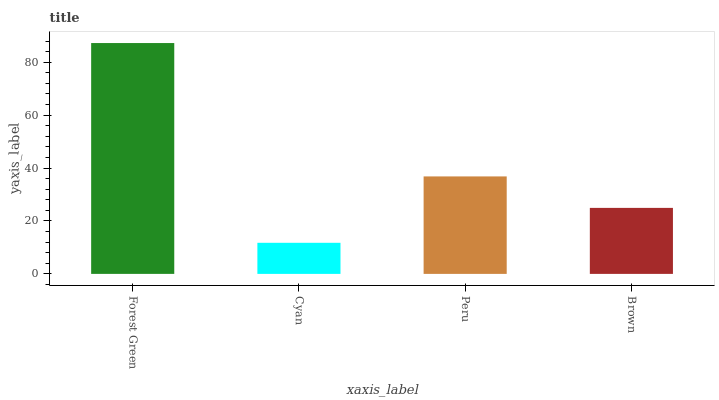Is Cyan the minimum?
Answer yes or no. Yes. Is Forest Green the maximum?
Answer yes or no. Yes. Is Peru the minimum?
Answer yes or no. No. Is Peru the maximum?
Answer yes or no. No. Is Peru greater than Cyan?
Answer yes or no. Yes. Is Cyan less than Peru?
Answer yes or no. Yes. Is Cyan greater than Peru?
Answer yes or no. No. Is Peru less than Cyan?
Answer yes or no. No. Is Peru the high median?
Answer yes or no. Yes. Is Brown the low median?
Answer yes or no. Yes. Is Brown the high median?
Answer yes or no. No. Is Forest Green the low median?
Answer yes or no. No. 